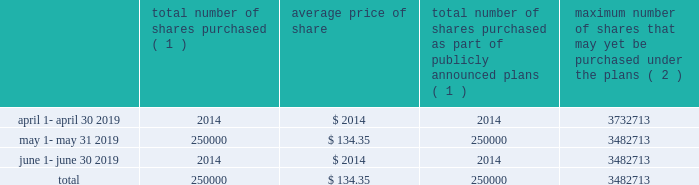J a c k h e n r y .
C o m 1 5 market for registrant 2019s common equity , related stockholder matters and issuer purchases of equity securities the company 2019s common stock is quoted on the nasdaq global select market ( 201cnasdaq 201d ) under the symbol 201cjkhy 201d .
The company established a practice of paying quarterly dividends at the end of fiscal 1990 and has paid dividends with respect to every quarter since that time .
The declaration and payment of any future dividends will continue to be at the discretion of our board of directors and will depend upon , among other factors , our earnings , capital requirements , contractual restrictions , and operating and financial condition .
The company does not currently foresee any changes in its dividend practices .
On august 15 , 2019 , there were approximately 145300 holders of the company 2019s common stock , including individual participants in security position listings .
On that same date the last sale price of the common shares as reported on nasdaq was $ 141.94 per share .
Issuer purchases of equity securities the following shares of the company were repurchased during the quarter ended june 30 , 2019 : total number of shares purchased ( 1 ) average price of total number of shares purchased as part of publicly announced plans ( 1 ) maximum number of shares that may yet be purchased under the plans ( 2 ) .
( 1 ) 250000 shares were purchased through a publicly announced repurchase plan .
There were no shares surrendered to the company to satisfy tax withholding obligations in connection with employee restricted stock awards .
( 2 ) total stock repurchase authorizations approved by the company 2019s board of directors as of february 17 , 2015 were for 30.0 million shares .
These authorizations have no specific dollar or share price targets and no expiration dates. .
What percent of the total years repurchases were done in the period from may 1- may 31 2019? 
Computations: (250000 / 250000)
Answer: 1.0. 